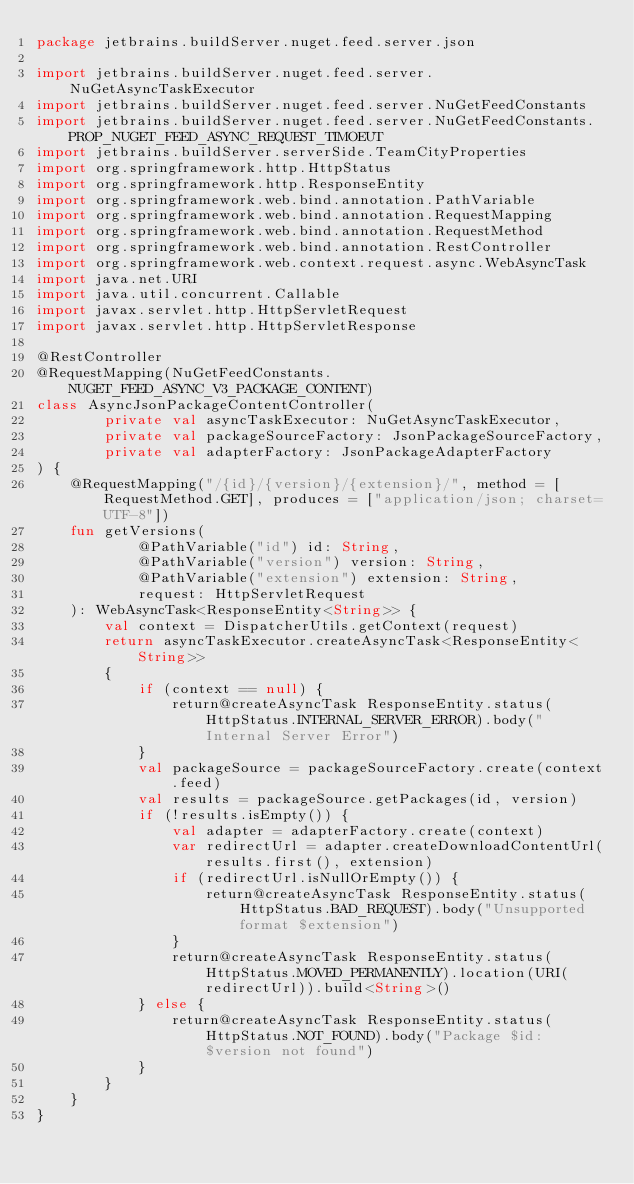Convert code to text. <code><loc_0><loc_0><loc_500><loc_500><_Kotlin_>package jetbrains.buildServer.nuget.feed.server.json

import jetbrains.buildServer.nuget.feed.server.NuGetAsyncTaskExecutor
import jetbrains.buildServer.nuget.feed.server.NuGetFeedConstants
import jetbrains.buildServer.nuget.feed.server.NuGetFeedConstants.PROP_NUGET_FEED_ASYNC_REQUEST_TIMOEUT
import jetbrains.buildServer.serverSide.TeamCityProperties
import org.springframework.http.HttpStatus
import org.springframework.http.ResponseEntity
import org.springframework.web.bind.annotation.PathVariable
import org.springframework.web.bind.annotation.RequestMapping
import org.springframework.web.bind.annotation.RequestMethod
import org.springframework.web.bind.annotation.RestController
import org.springframework.web.context.request.async.WebAsyncTask
import java.net.URI
import java.util.concurrent.Callable
import javax.servlet.http.HttpServletRequest
import javax.servlet.http.HttpServletResponse

@RestController
@RequestMapping(NuGetFeedConstants. NUGET_FEED_ASYNC_V3_PACKAGE_CONTENT)
class AsyncJsonPackageContentController(
        private val asyncTaskExecutor: NuGetAsyncTaskExecutor,
        private val packageSourceFactory: JsonPackageSourceFactory,
        private val adapterFactory: JsonPackageAdapterFactory
) {
    @RequestMapping("/{id}/{version}/{extension}/", method = [RequestMethod.GET], produces = ["application/json; charset=UTF-8"])
    fun getVersions(
            @PathVariable("id") id: String,
            @PathVariable("version") version: String,
            @PathVariable("extension") extension: String,
            request: HttpServletRequest
    ): WebAsyncTask<ResponseEntity<String>> {
        val context = DispatcherUtils.getContext(request)
        return asyncTaskExecutor.createAsyncTask<ResponseEntity<String>>
        {
            if (context == null) {
                return@createAsyncTask ResponseEntity.status(HttpStatus.INTERNAL_SERVER_ERROR).body("Internal Server Error")
            }
            val packageSource = packageSourceFactory.create(context.feed)
            val results = packageSource.getPackages(id, version)
            if (!results.isEmpty()) {
                val adapter = adapterFactory.create(context)
                var redirectUrl = adapter.createDownloadContentUrl(results.first(), extension)
                if (redirectUrl.isNullOrEmpty()) {
                    return@createAsyncTask ResponseEntity.status(HttpStatus.BAD_REQUEST).body("Unsupported format $extension")
                }
                return@createAsyncTask ResponseEntity.status(HttpStatus.MOVED_PERMANENTLY).location(URI(redirectUrl)).build<String>()
            } else {
                return@createAsyncTask ResponseEntity.status(HttpStatus.NOT_FOUND).body("Package $id:$version not found")
            }
        }
    }
}
</code> 